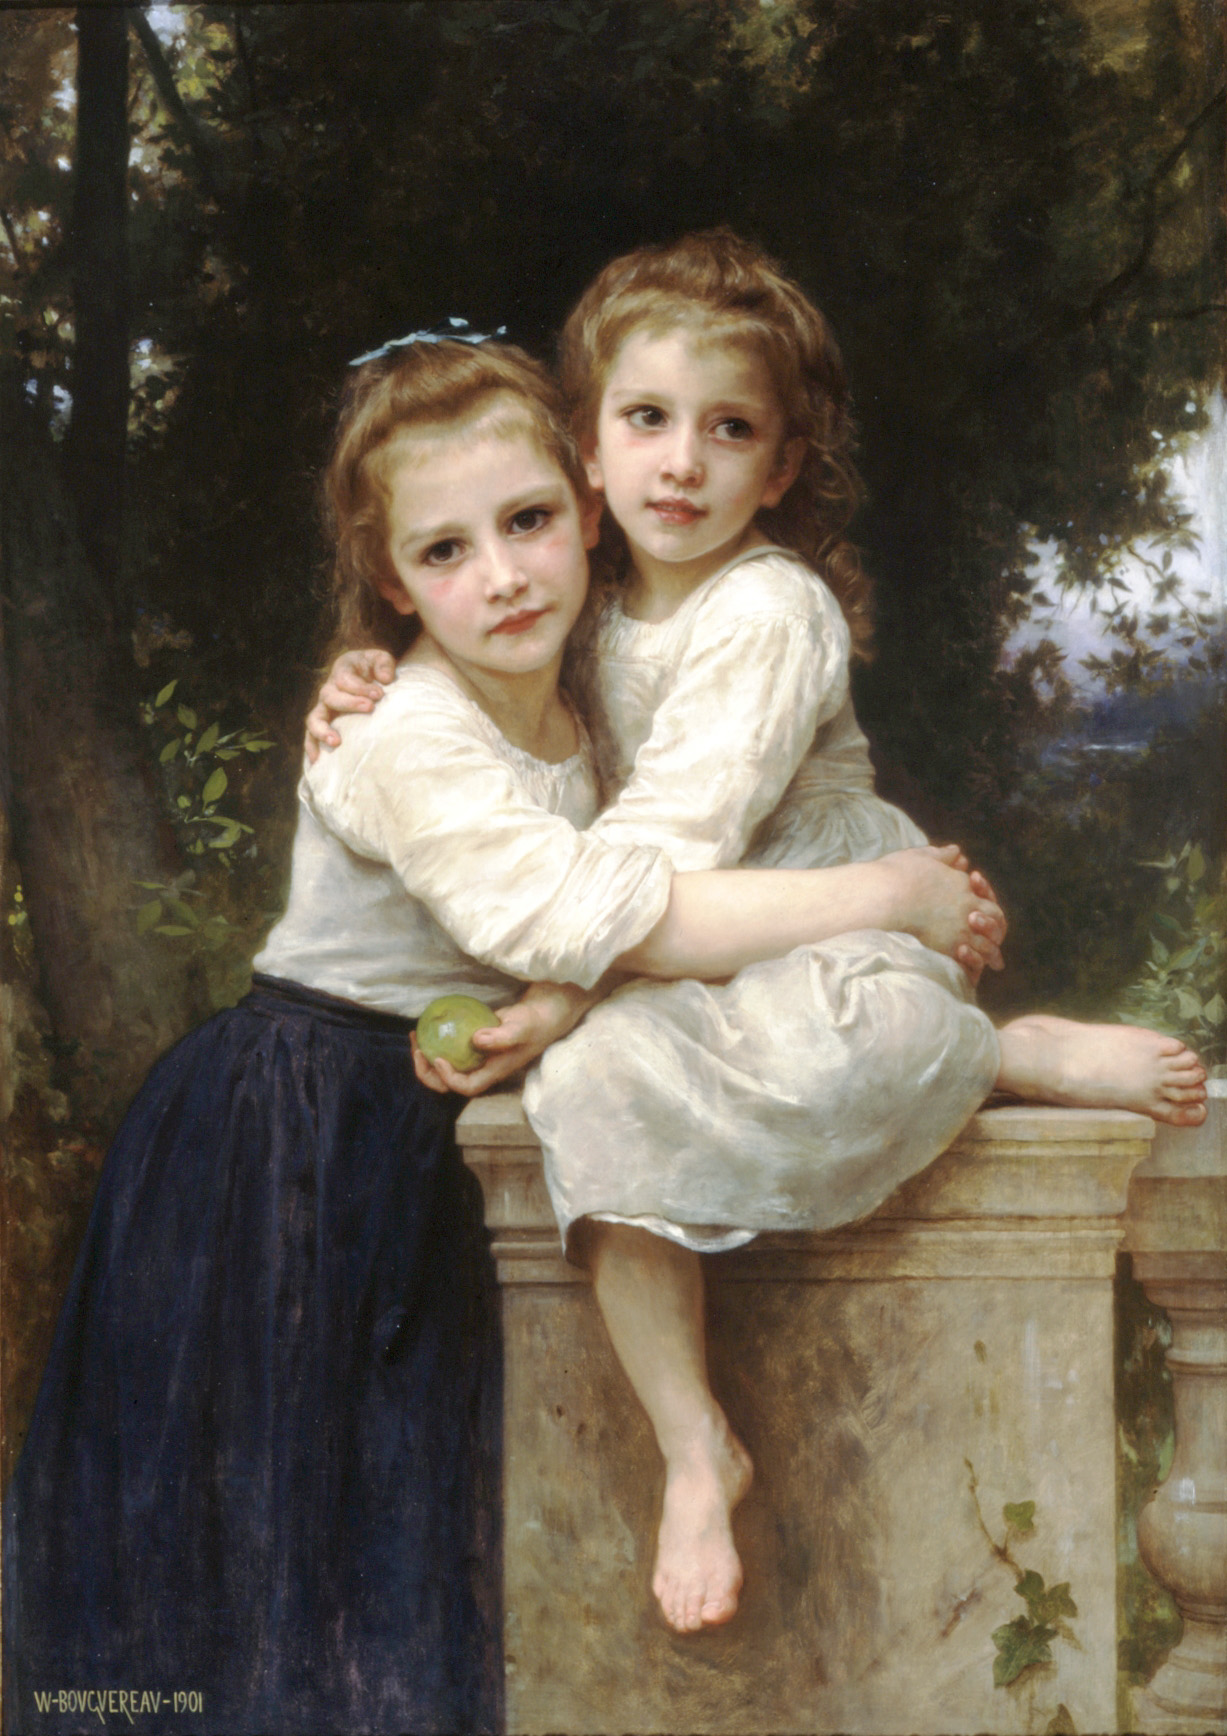Could you speak to the artistic technique used in this painting? The painting showcases a refined realistic technique, evident through the detailed rendering of the subjects' skin, hair, and clothing. The artist's use of light and shadow creates a three-dimensional effect, adding depth and volume to the figures. The brushstrokes are delicate and meticulous, which is particularly noticeable in the gentle play of light across the fabric of the dresses and the crisp edges of foliage in the background. This technique results in a tangible and intimate portrait that feels both lifelike and idealized. 